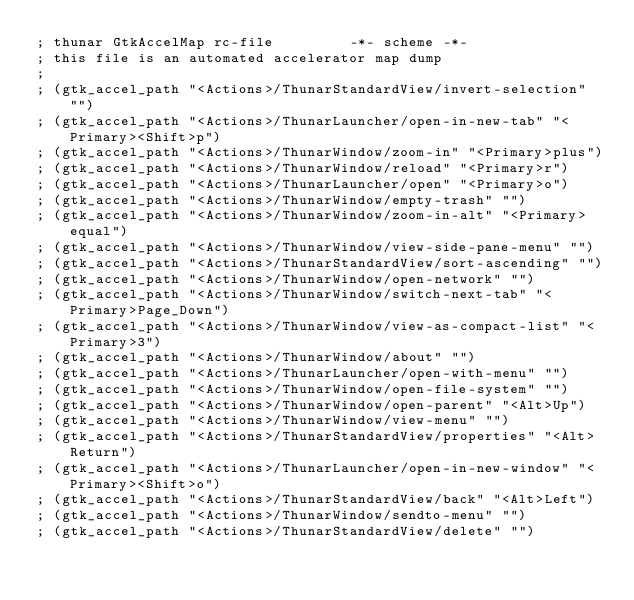Convert code to text. <code><loc_0><loc_0><loc_500><loc_500><_Scheme_>; thunar GtkAccelMap rc-file         -*- scheme -*-
; this file is an automated accelerator map dump
;
; (gtk_accel_path "<Actions>/ThunarStandardView/invert-selection" "")
; (gtk_accel_path "<Actions>/ThunarLauncher/open-in-new-tab" "<Primary><Shift>p")
; (gtk_accel_path "<Actions>/ThunarWindow/zoom-in" "<Primary>plus")
; (gtk_accel_path "<Actions>/ThunarWindow/reload" "<Primary>r")
; (gtk_accel_path "<Actions>/ThunarLauncher/open" "<Primary>o")
; (gtk_accel_path "<Actions>/ThunarWindow/empty-trash" "")
; (gtk_accel_path "<Actions>/ThunarWindow/zoom-in-alt" "<Primary>equal")
; (gtk_accel_path "<Actions>/ThunarWindow/view-side-pane-menu" "")
; (gtk_accel_path "<Actions>/ThunarStandardView/sort-ascending" "")
; (gtk_accel_path "<Actions>/ThunarWindow/open-network" "")
; (gtk_accel_path "<Actions>/ThunarWindow/switch-next-tab" "<Primary>Page_Down")
; (gtk_accel_path "<Actions>/ThunarWindow/view-as-compact-list" "<Primary>3")
; (gtk_accel_path "<Actions>/ThunarWindow/about" "")
; (gtk_accel_path "<Actions>/ThunarLauncher/open-with-menu" "")
; (gtk_accel_path "<Actions>/ThunarWindow/open-file-system" "")
; (gtk_accel_path "<Actions>/ThunarWindow/open-parent" "<Alt>Up")
; (gtk_accel_path "<Actions>/ThunarWindow/view-menu" "")
; (gtk_accel_path "<Actions>/ThunarStandardView/properties" "<Alt>Return")
; (gtk_accel_path "<Actions>/ThunarLauncher/open-in-new-window" "<Primary><Shift>o")
; (gtk_accel_path "<Actions>/ThunarStandardView/back" "<Alt>Left")
; (gtk_accel_path "<Actions>/ThunarWindow/sendto-menu" "")
; (gtk_accel_path "<Actions>/ThunarStandardView/delete" "")</code> 